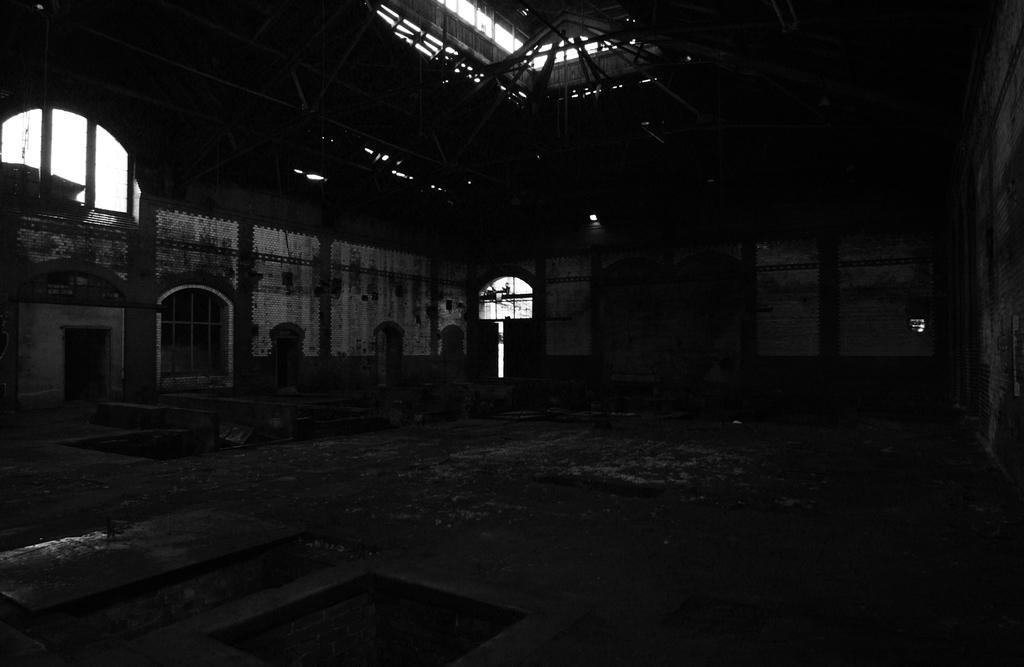How would you summarize this image in a sentence or two? In this image I can see walls, windows and some other objects on the ground. This image is dark. 